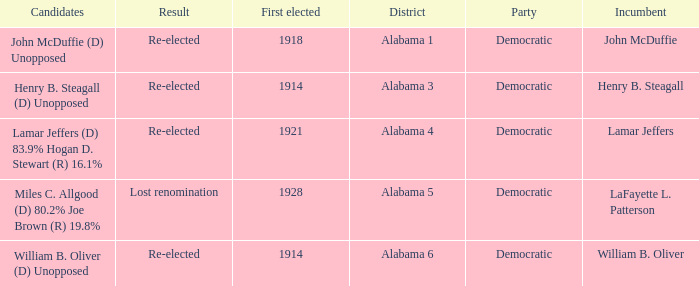How many in total were elected first in lost renomination? 1.0. 